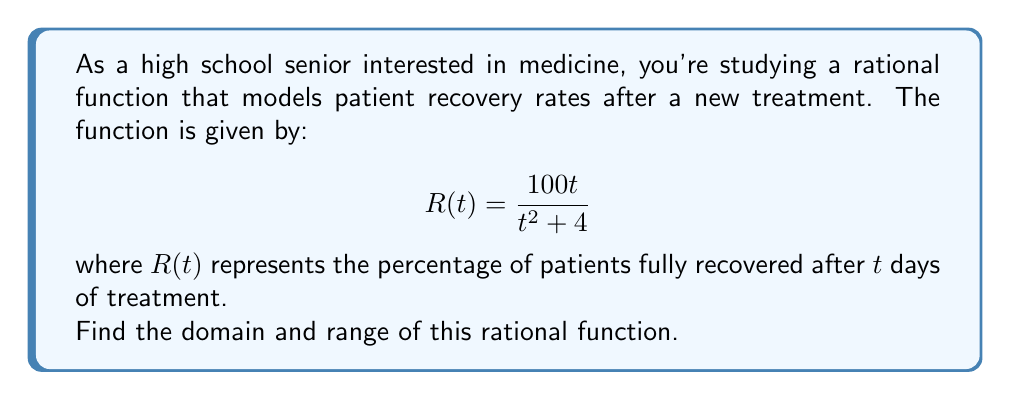What is the answer to this math problem? Let's approach this step-by-step:

1) Domain:
   The domain of a rational function includes all real numbers except those that make the denominator zero.
   
   Set the denominator to zero and solve:
   $$t^2 + 4 = 0$$
   $$t^2 = -4$$
   
   This equation has no real solutions because a squared term can't be negative.
   Therefore, the denominator is never zero for any real value of $t$.

   Additionally, since $t$ represents time (in days), it can't be negative.
   
   Thus, the domain is all non-negative real numbers: $[0,\infty)$

2) Range:
   To find the range, let's analyze the behavior of the function:

   a) As $t$ approaches infinity:
      $$\lim_{t \to \infty} R(t) = \lim_{t \to \infty} \frac{100t}{t^2 + 4} = \lim_{t \to \infty} \frac{100}{t + 4/t} = 0$$

   b) As $t$ approaches 0 from the right:
      $$\lim_{t \to 0^+} R(t) = \lim_{t \to 0^+} \frac{100t}{t^2 + 4} = 0$$

   c) To find the maximum value, let's find the critical points:
      $$R'(t) = \frac{100(t^2 + 4) - 100t(2t)}{(t^2 + 4)^2} = \frac{100(4 - t^2)}{(t^2 + 4)^2}$$
      
      Set $R'(t) = 0$:
      $$100(4 - t^2) = 0$$
      $$4 - t^2 = 0$$
      $$t^2 = 4$$
      $$t = \pm 2$$

      Since $t$ can't be negative, we only consider $t = 2$.

   d) The maximum value occurs at $t = 2$:
      $$R(2) = \frac{100(2)}{2^2 + 4} = \frac{200}{8} = 25$$

Therefore, the range of the function is $[0,25]$.
Answer: Domain: $[0,\infty)$, Range: $[0,25]$ 